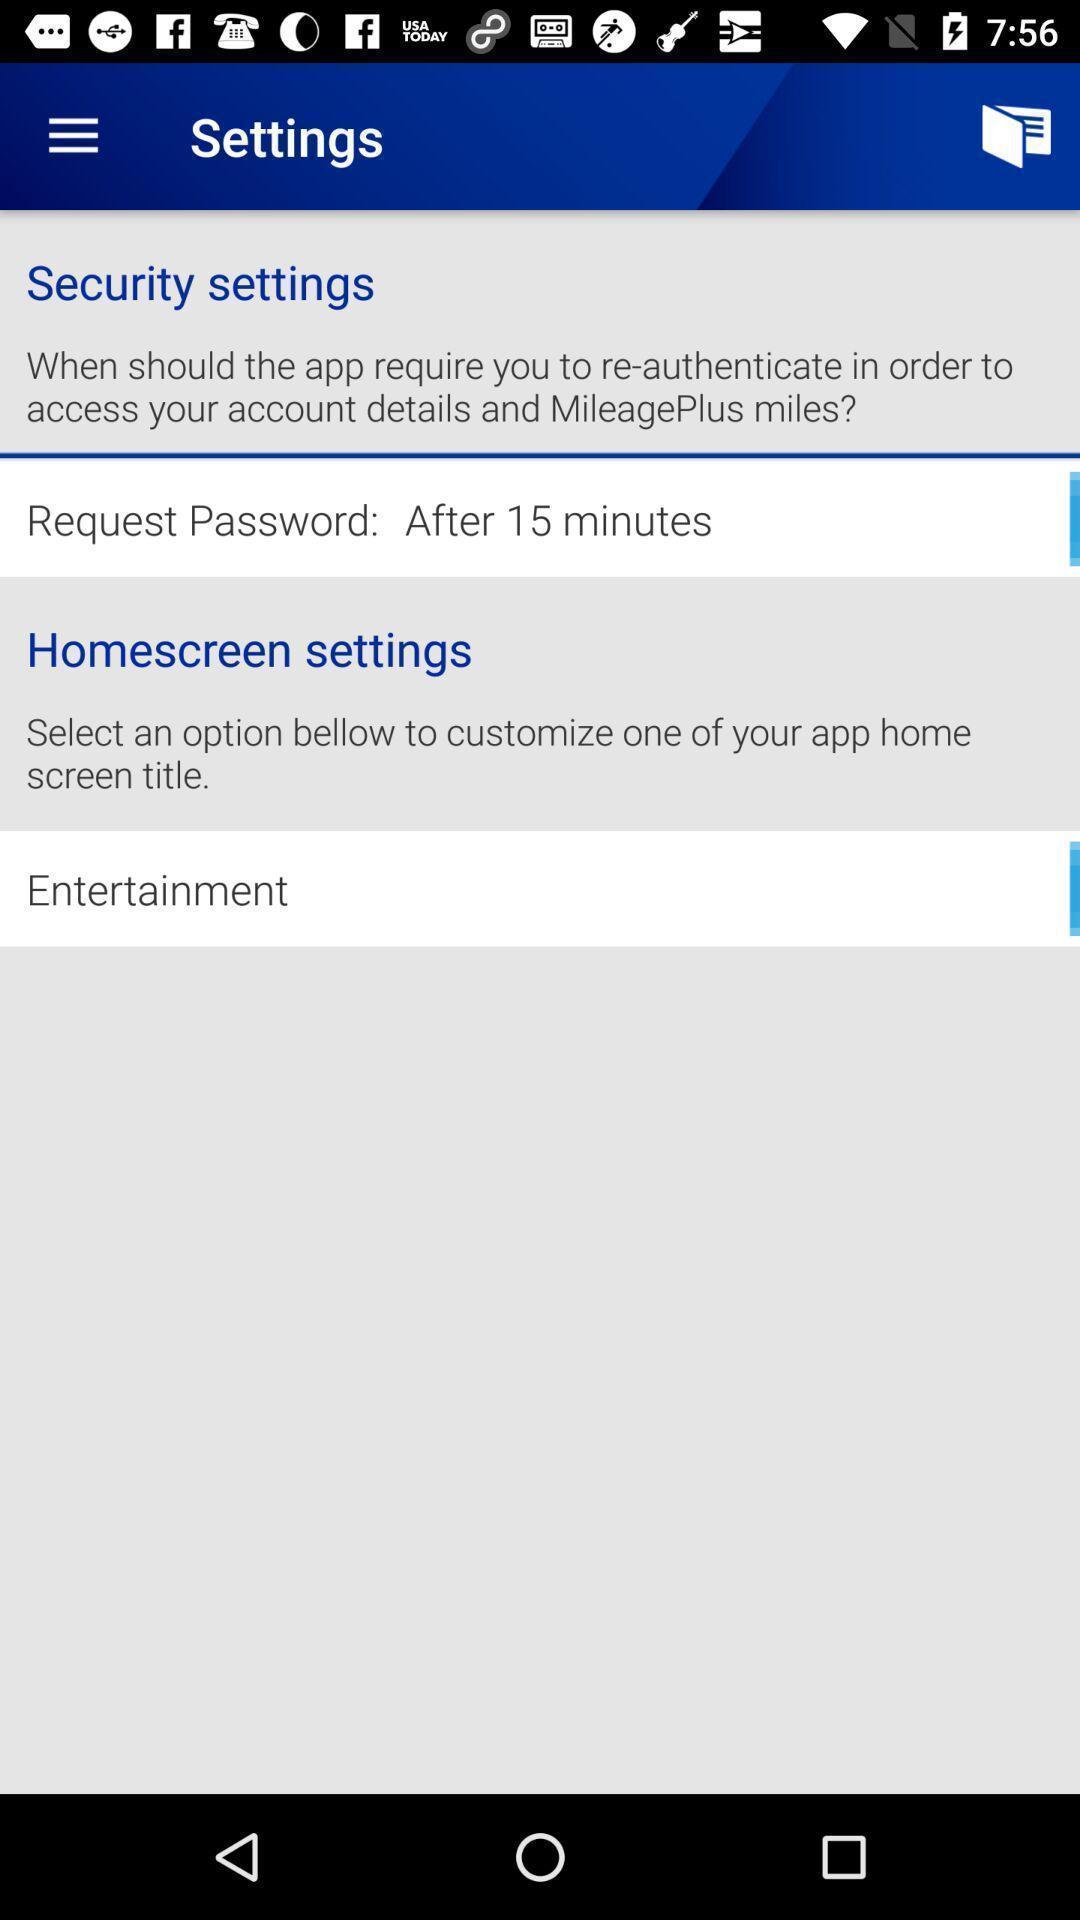Explain the elements present in this screenshot. Settings page with various options. 